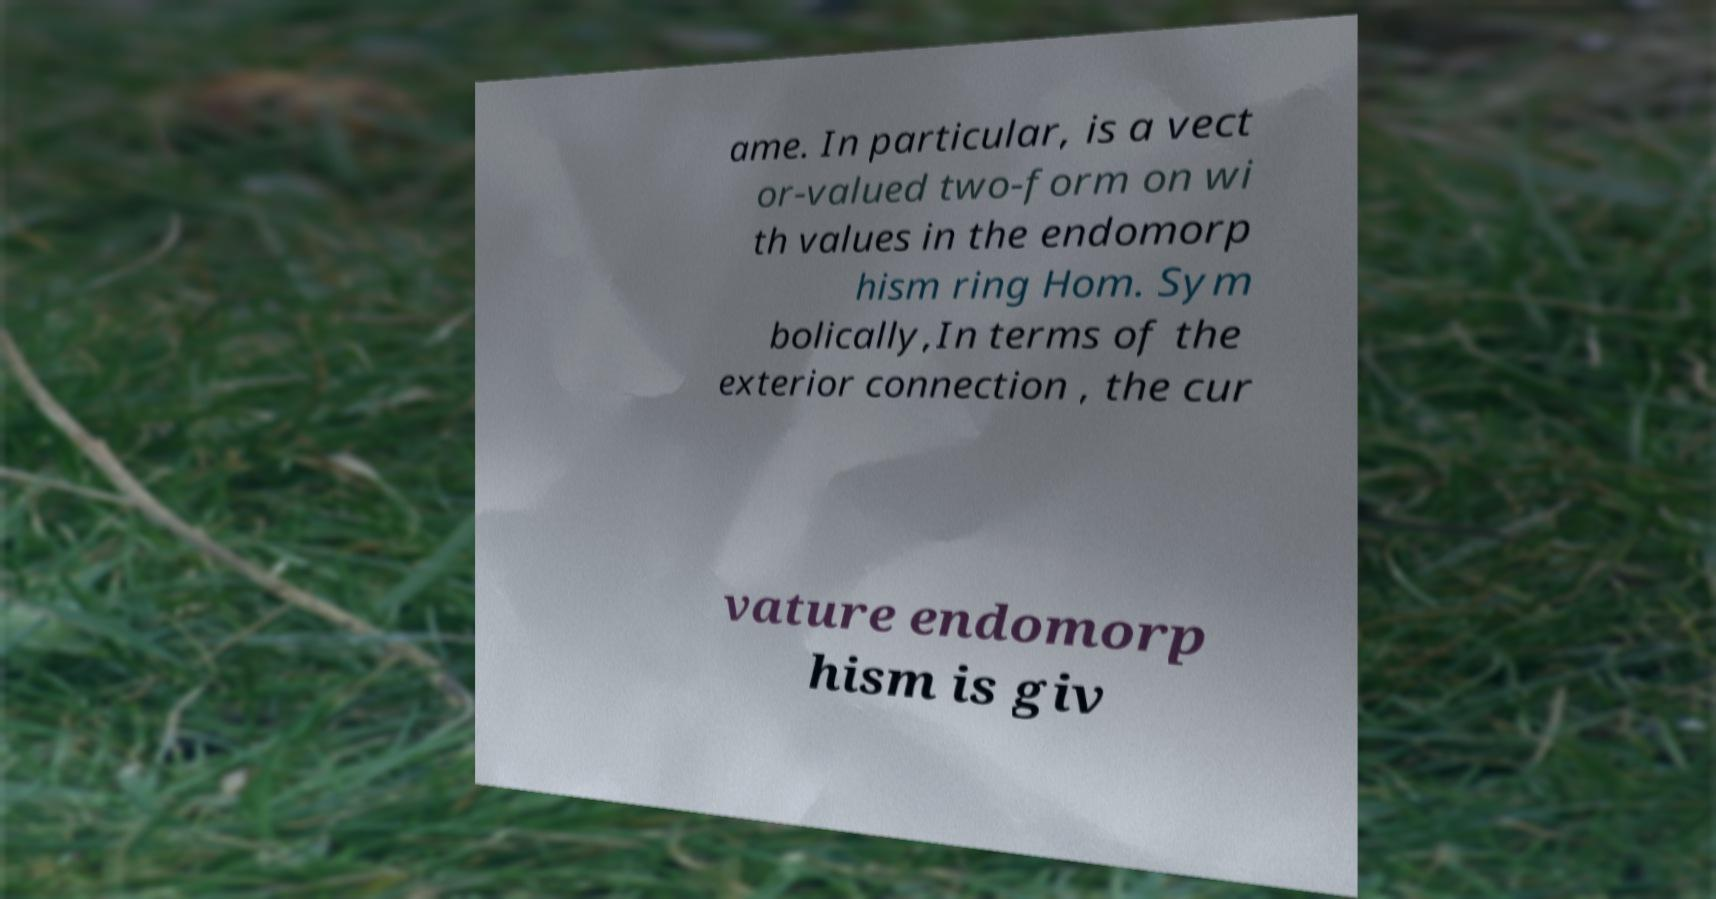There's text embedded in this image that I need extracted. Can you transcribe it verbatim? ame. In particular, is a vect or-valued two-form on wi th values in the endomorp hism ring Hom. Sym bolically,In terms of the exterior connection , the cur vature endomorp hism is giv 